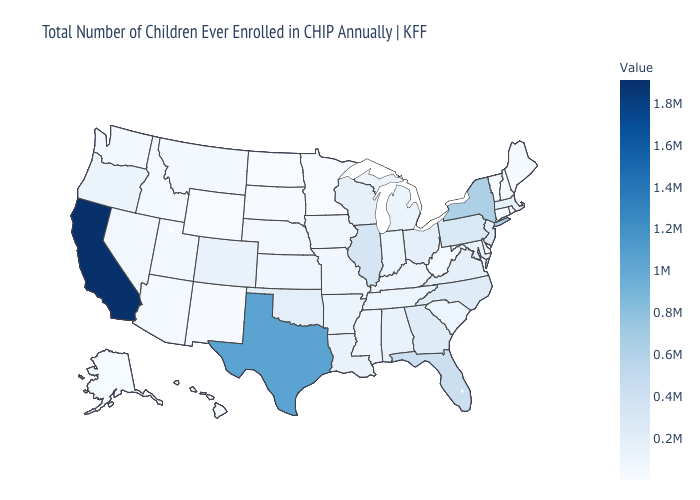Among the states that border Tennessee , does North Carolina have the highest value?
Short answer required. Yes. Which states hav the highest value in the MidWest?
Short answer required. Illinois. Is the legend a continuous bar?
Answer briefly. Yes. Among the states that border Connecticut , which have the highest value?
Keep it brief. New York. Does Colorado have the highest value in the USA?
Write a very short answer. No. Does Oklahoma have the highest value in the USA?
Be succinct. No. Which states have the highest value in the USA?
Give a very brief answer. California. 